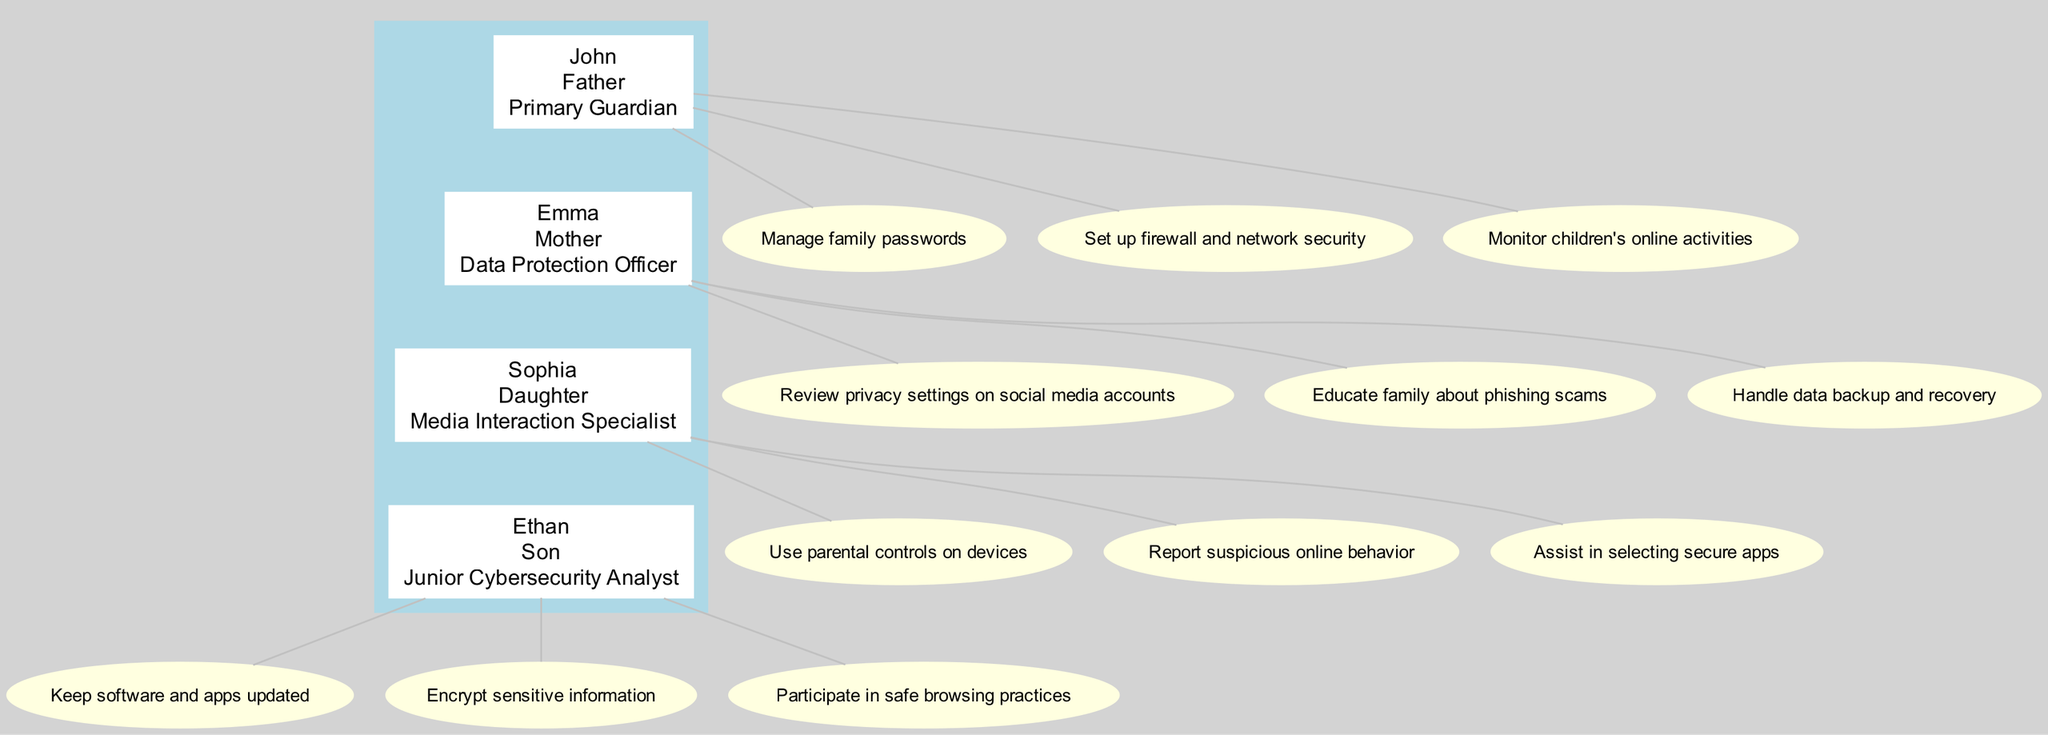What is John’s role in the family? John's role is specified as the "Primary Guardian." This can be identified from the details provided in the diagram where each member's name is associated with their respective roles.
Answer: Primary Guardian Who is responsible for reviewing privacy settings on social media accounts? Emma has the responsibility for reviewing privacy settings on social media accounts, as listed under her responsibilities in the diagram.
Answer: Emma How many responsibilities does Sophia have? By counting the responsibilities listed under Sophia's name in the diagram, there are a total of three responsibilities indicated.
Answer: 3 Which family member is tasked with managing family passwords? According to the diagram, the task of managing family passwords is explicitly assigned to John, as shown in his list of responsibilities.
Answer: John Which member assists in selecting secure apps? Based on the diagram, Sophia is the one who assists in selecting secure apps, indicated as one of her specific roles in media interaction.
Answer: Sophia What role does Ethan play in terms of cybersecurity? Ethan's role is indicated as "Junior Cybersecurity Analyst" from the node that describes him, revealing his specific focus on handling cybersecurity tasks.
Answer: Junior Cybersecurity Analyst Which family member educates others about phishing scams? According to the information contained in the diagram under Emma's responsibilities, she is responsible for educating the family about phishing scams.
Answer: Emma How many family members are part of the privacy and security structure? The diagram displays four family members: John, Emma, Sophia, and Ethan. Identifying and counting the members from the diagram leads to this conclusion.
Answer: 4 What is the relationship of Sophia to John? The diagram articulates that Sophia is John’s daughter, establishing the familial relationship between these two members in the structure.
Answer: Daughter Who monitors children’s online activities? The responsibility of monitoring children’s online activities is assigned to John, which can be seen in his responsibilities outlined in the diagram.
Answer: John 